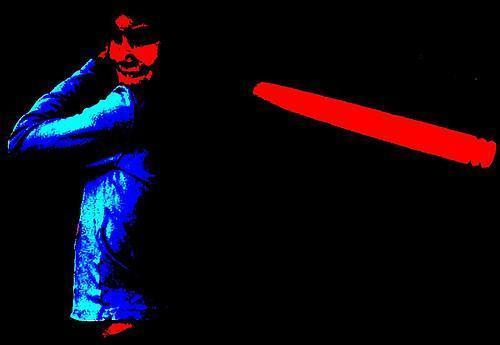How many boats do you see?
Give a very brief answer. 0. 